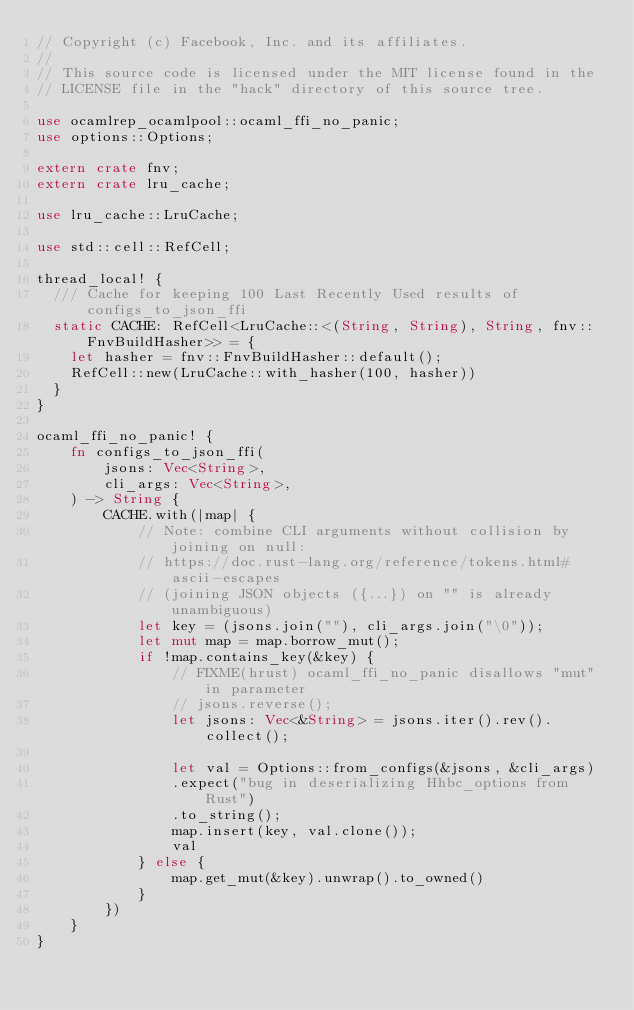<code> <loc_0><loc_0><loc_500><loc_500><_Rust_>// Copyright (c) Facebook, Inc. and its affiliates.
//
// This source code is licensed under the MIT license found in the
// LICENSE file in the "hack" directory of this source tree.

use ocamlrep_ocamlpool::ocaml_ffi_no_panic;
use options::Options;

extern crate fnv;
extern crate lru_cache;

use lru_cache::LruCache;

use std::cell::RefCell;

thread_local! {
  /// Cache for keeping 100 Last Recently Used results of configs_to_json_ffi
  static CACHE: RefCell<LruCache::<(String, String), String, fnv::FnvBuildHasher>> = {
    let hasher = fnv::FnvBuildHasher::default();
    RefCell::new(LruCache::with_hasher(100, hasher))
  }
}

ocaml_ffi_no_panic! {
    fn configs_to_json_ffi(
        jsons: Vec<String>,
        cli_args: Vec<String>,
    ) -> String {
        CACHE.with(|map| {
            // Note: combine CLI arguments without collision by joining on null:
            // https://doc.rust-lang.org/reference/tokens.html#ascii-escapes
            // (joining JSON objects ({...}) on "" is already unambiguous)
            let key = (jsons.join(""), cli_args.join("\0"));
            let mut map = map.borrow_mut();
            if !map.contains_key(&key) {
                // FIXME(hrust) ocaml_ffi_no_panic disallows "mut" in parameter
                // jsons.reverse();
                let jsons: Vec<&String> = jsons.iter().rev().collect();

                let val = Options::from_configs(&jsons, &cli_args)
                .expect("bug in deserializing Hhbc_options from Rust")
                .to_string();
                map.insert(key, val.clone());
                val
            } else {
                map.get_mut(&key).unwrap().to_owned()
            }
        })
    }
}
</code> 